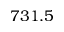Convert formula to latex. <formula><loc_0><loc_0><loc_500><loc_500>7 3 1 . 5</formula> 